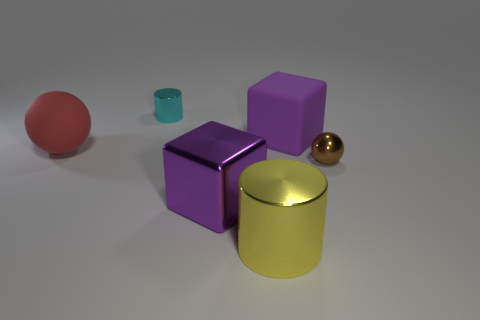How many things are blue rubber spheres or purple matte things?
Your response must be concise. 1. What is the shape of the big object that is both behind the brown object and on the right side of the metal cube?
Give a very brief answer. Cube. Is the big purple cube to the right of the metallic cube made of the same material as the large red ball?
Give a very brief answer. Yes. How many things are either cyan rubber spheres or large purple objects to the right of the big yellow cylinder?
Your response must be concise. 1. There is a large object that is the same material as the large sphere; what color is it?
Make the answer very short. Purple. What number of yellow objects have the same material as the tiny brown sphere?
Offer a very short reply. 1. What number of cyan objects are there?
Offer a terse response. 1. Is the color of the cube in front of the tiny brown metal thing the same as the ball that is behind the metallic ball?
Make the answer very short. No. How many tiny cyan metal things are in front of the tiny brown object?
Offer a very short reply. 0. What material is the object that is the same color as the shiny cube?
Make the answer very short. Rubber. 